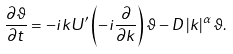Convert formula to latex. <formula><loc_0><loc_0><loc_500><loc_500>\frac { \partial \vartheta } { \partial t } = - i k U ^ { \prime } \left ( - i \frac { \partial } { \partial k } \right ) \vartheta - D \left | k \right | ^ { \alpha } \vartheta . \,</formula> 